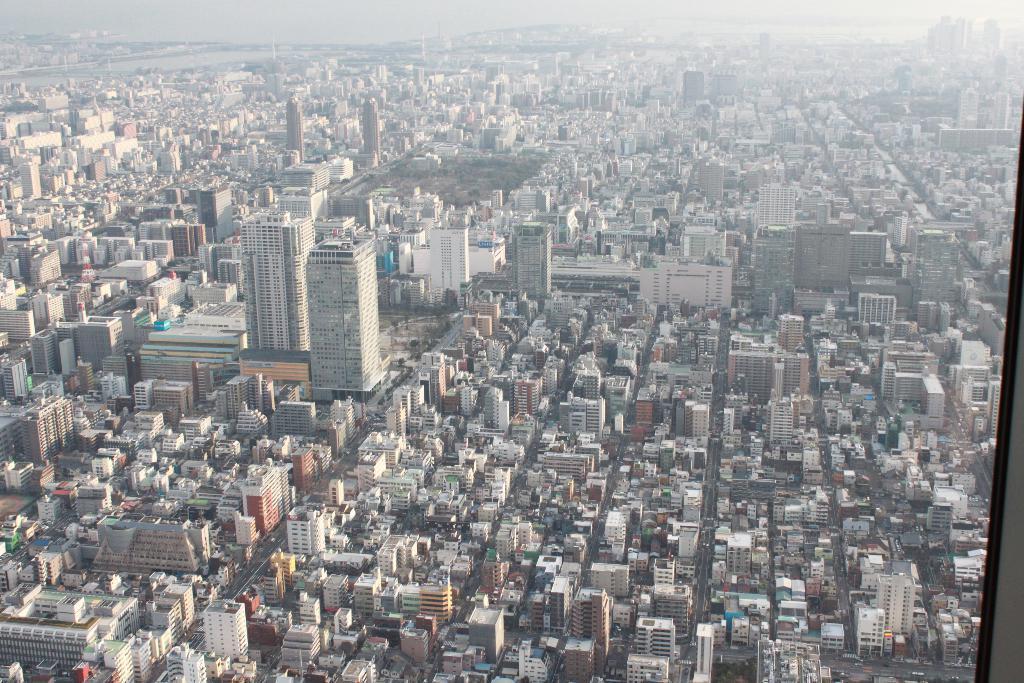How would you summarize this image in a sentence or two? In this picture we can see buildings and this is sky. 